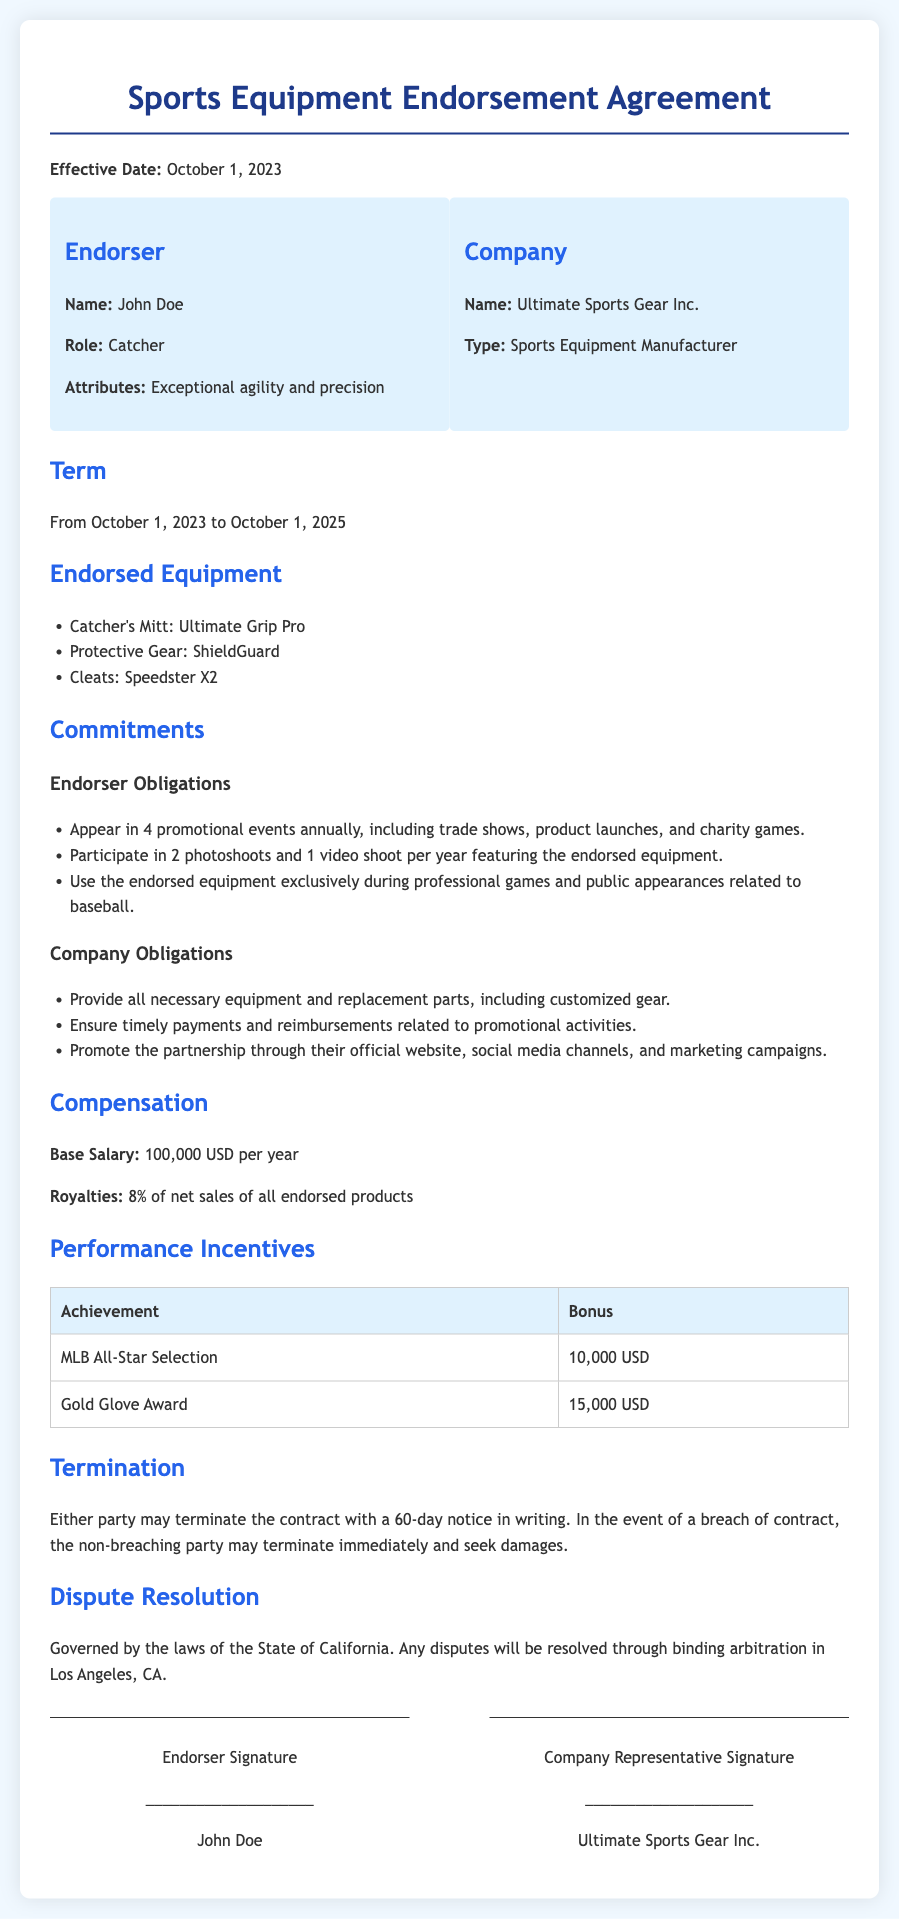what is the effective date of the contract? The effective date of the contract is clearly stated in the document as October 1, 2023.
Answer: October 1, 2023 who is the endorser? The name of the endorser mentioned in the contract is provided in the parties section.
Answer: John Doe what is the base salary for the endorser? The base salary is specified under the Compensation section of the document.
Answer: 100,000 USD per year how long is the term of the agreement? The term of the agreement is shown in the Term section.
Answer: From October 1, 2023 to October 1, 2025 what percentage of net sales does the endorser receive as royalties? The royalties percentage is detailed in the Compensation section.
Answer: 8% what is one of the obligations of the endorser? Obligations for the endorser are listed in the Commitments section, providing specific duties to fulfill.
Answer: Appear in 4 promotional events annually what happens if there is a breach of contract? The consequences of a breach of contract are explained in the Termination section.
Answer: Terminate immediately and seek damages in which state is the dispute resolution governed? The related details about dispute resolution are included in the Dispute Resolution section.
Answer: California what is the bonus for receiving a Gold Glove Award? This bonus is mentioned in the Performance Incentives table.
Answer: 15,000 USD 